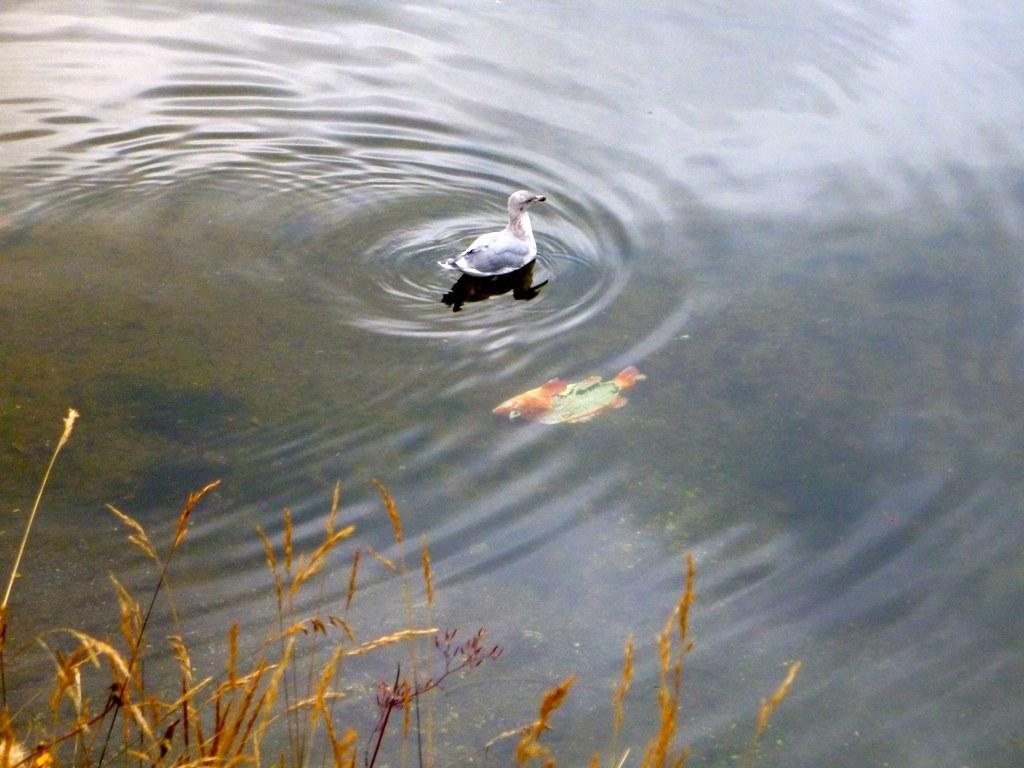What animal can be seen on the water in the image? There is a duck on the water in the image. What other creature is present in the water in the image? There is a fish in the water in the image. What type of vegetation is visible at the bottom of the image? There is grass at the bottom of the image. How many passengers are on the duck in the image? There are no passengers on the duck in the image, as it is a living creature and not a mode of transportation. 